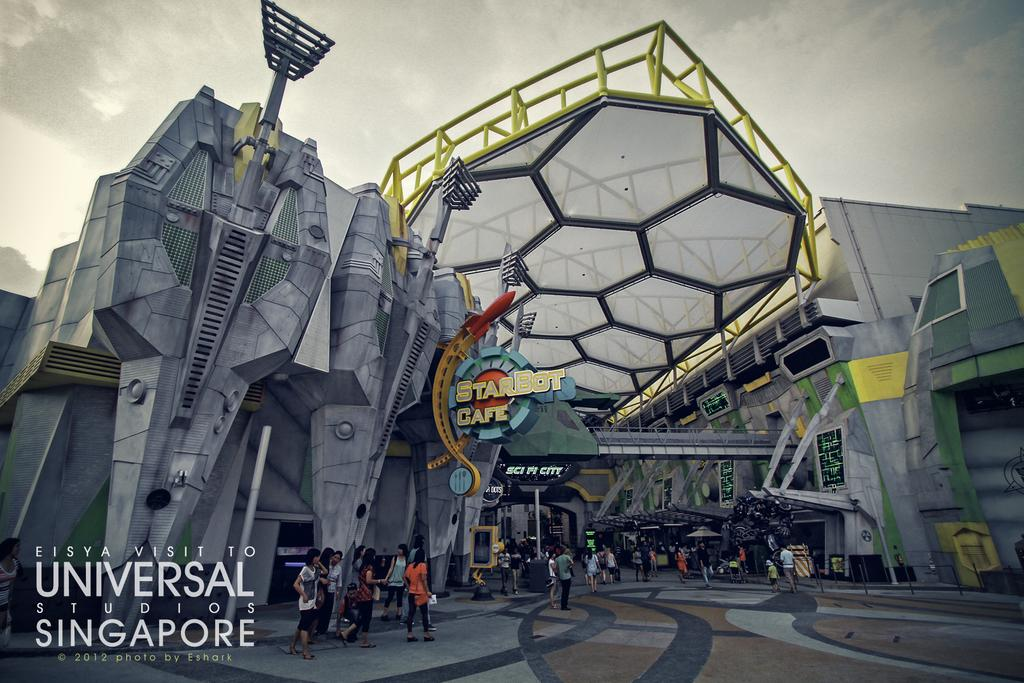What location is depicted in the image? The image is of Universal Studios in Singapore. What can be seen in the image besides the location? There are groups of people standing in the image. What is visible in the sky in the image? The sky is visible in the image. Is there any text or logo on the image? Yes, there is a watermark on the image. What type of pump is being used by the people in the image? There is no pump present in the image; it is a photo of Universal Studios in Singapore with groups of people standing in it. 